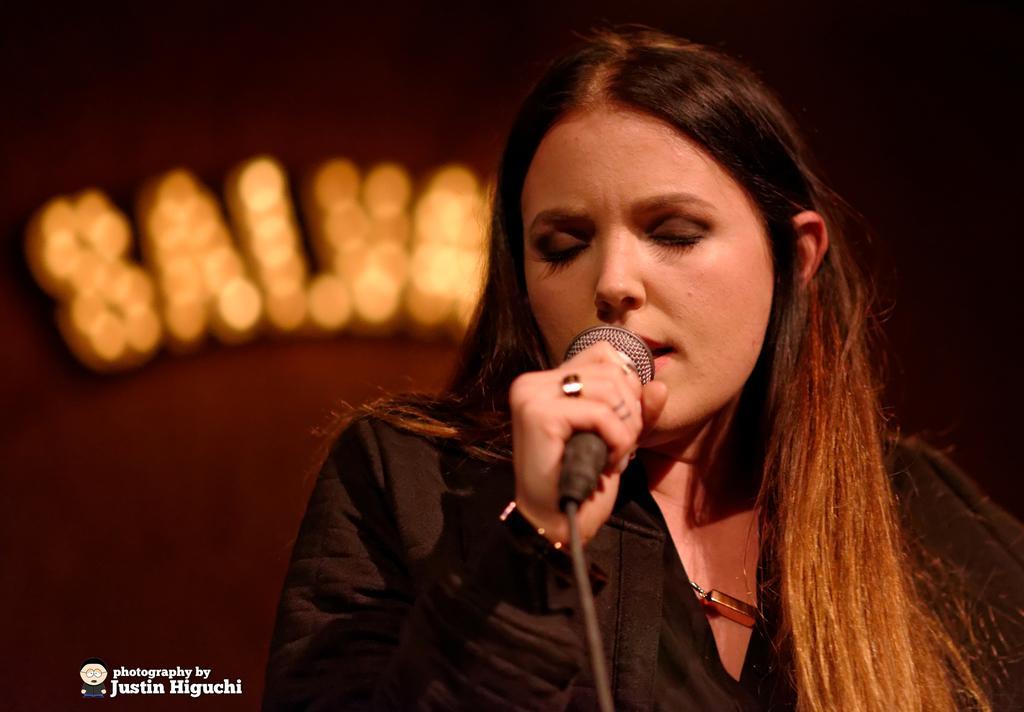Describe this image in one or two sentences. In the middle there is a woman she is wearing a black beautiful dress ,she is holding a mic ,i think she is singing. In the background there is a text with lights. 